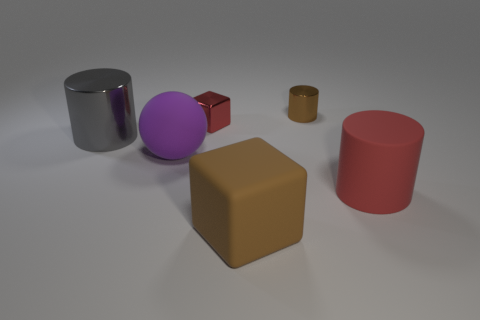Subtract all big gray metallic cylinders. How many cylinders are left? 2 Add 2 cylinders. How many objects exist? 8 Subtract all red blocks. How many blocks are left? 1 Subtract all spheres. How many objects are left? 5 Subtract all gray metal cylinders. Subtract all small metallic cylinders. How many objects are left? 4 Add 2 brown metallic cylinders. How many brown metallic cylinders are left? 3 Add 2 big gray things. How many big gray things exist? 3 Subtract 0 blue spheres. How many objects are left? 6 Subtract 1 cylinders. How many cylinders are left? 2 Subtract all blue balls. Subtract all gray cubes. How many balls are left? 1 